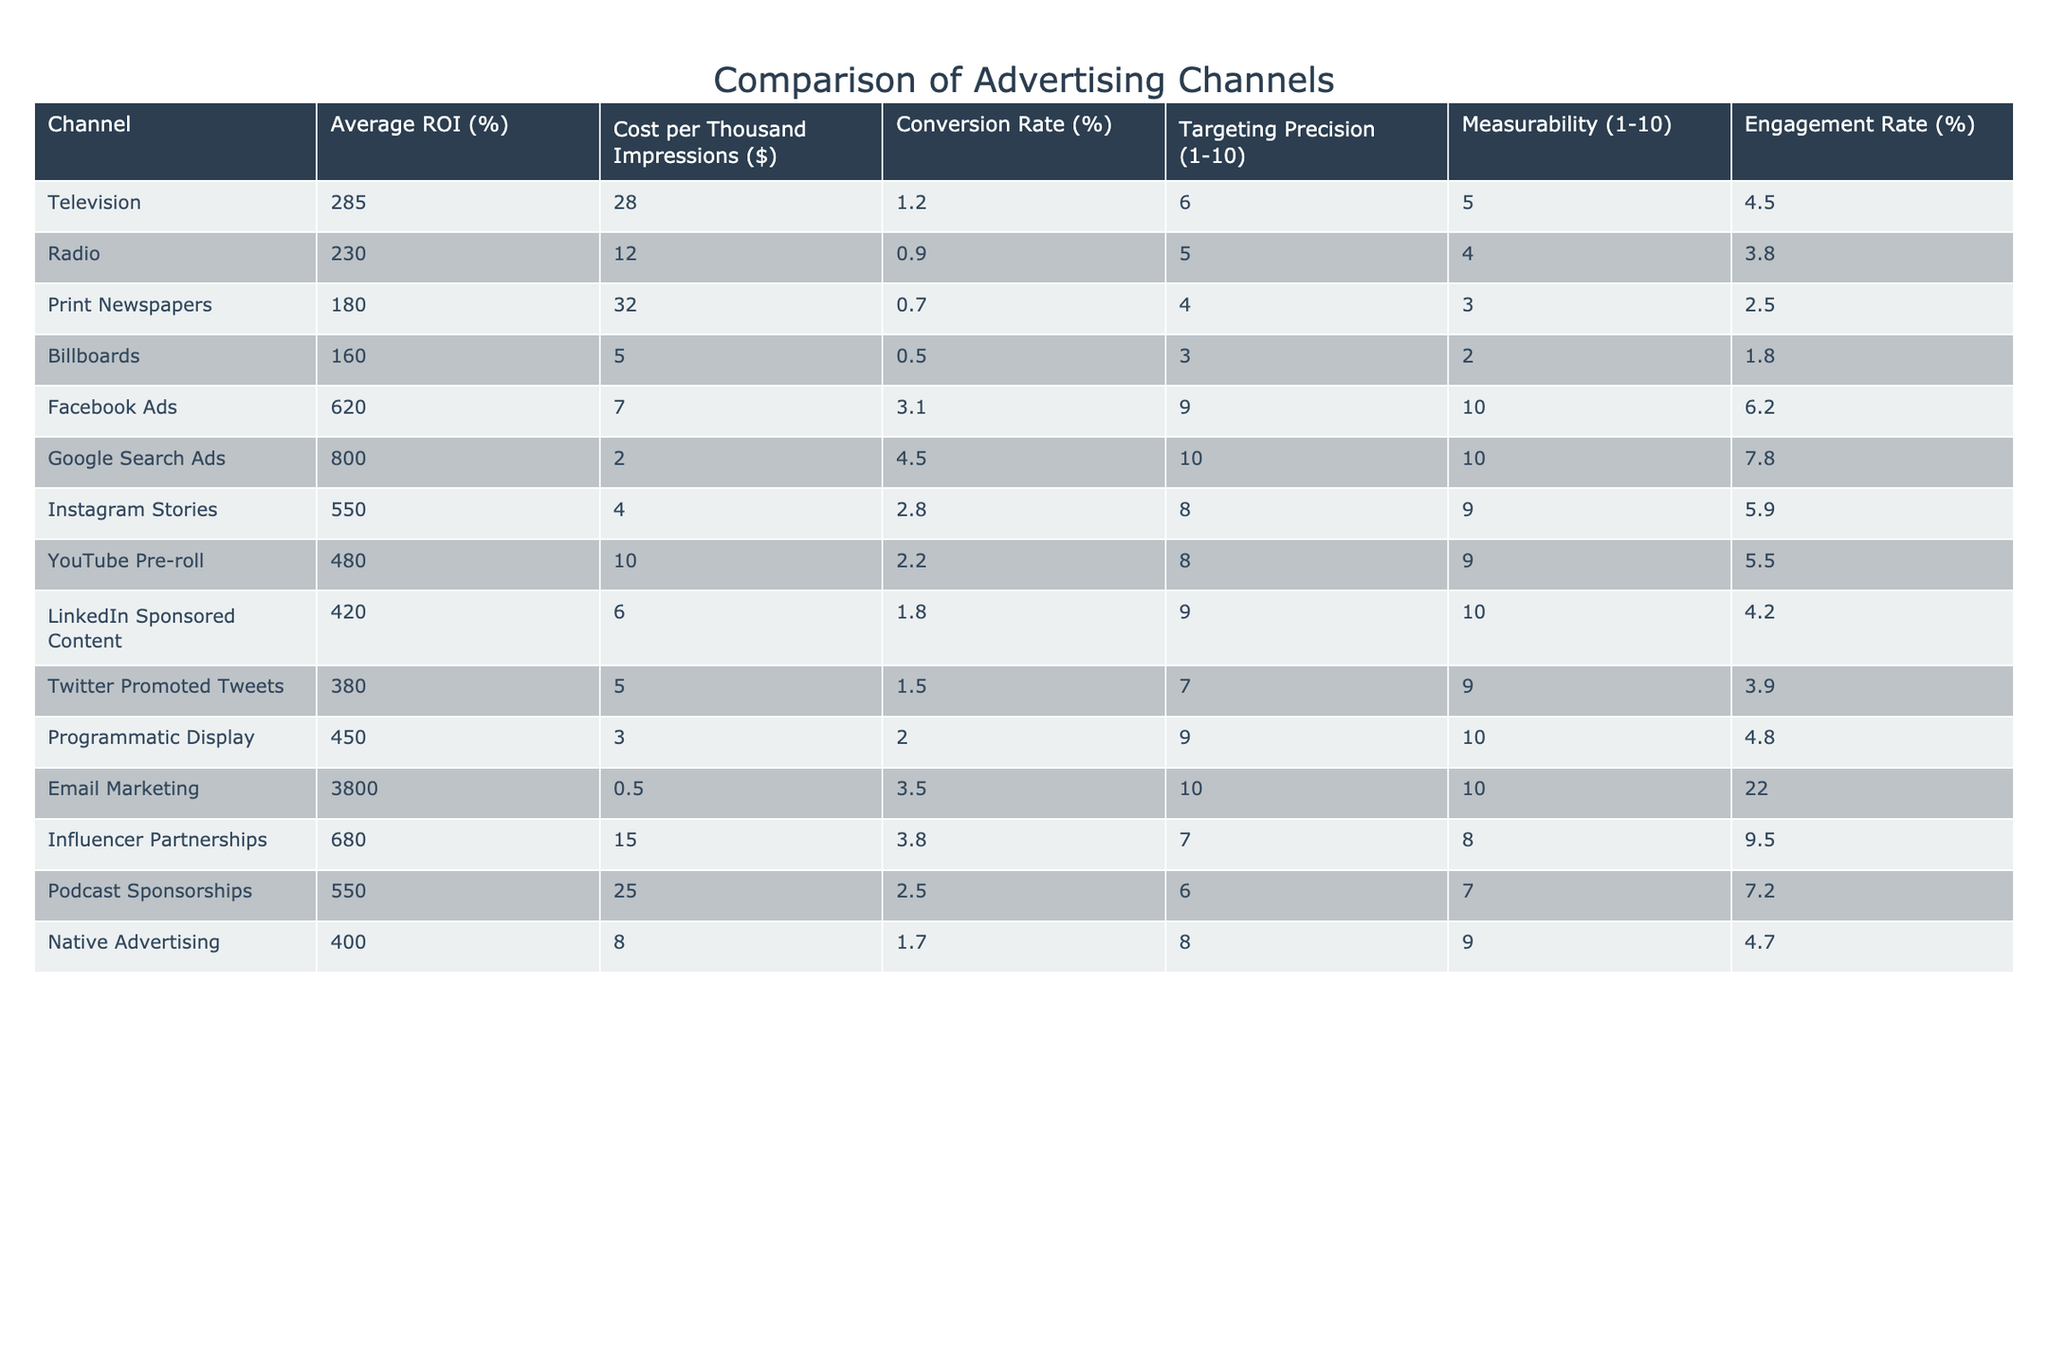What is the average ROI for digital advertising channels listed in the table? The digital advertising channels included are Facebook Ads, Google Search Ads, Instagram Stories, YouTube Pre-roll, LinkedIn Sponsored Content, Twitter Promoted Tweets, Programmatic Display, Email Marketing, Influencer Partnerships, Podcast Sponsorships, and Native Advertising. Their respective ROIs are 620, 800, 550, 480, 420, 380, 450, 3800, 680, 550, and 400. The sum of these values is 7920, and since there are 11 channels, the average ROI is 7920/11 = 720.
Answer: 720 Which traditional advertising channel has the highest conversion rate? The traditional advertising channels in the table are Television, Radio, Print Newspapers, and Billboards, with conversion rates of 1.2%, 0.9%, 0.7%, and 0.5%, respectively. Television has the highest conversion rate at 1.2%.
Answer: 1.2% Is the targeting precision of Google Search Ads higher than that of Facebook Ads? Google Search Ads has a targeting precision score of 10, while Facebook Ads has a score of 9. Since 10 is greater than 9, the targeting precision of Google Search Ads is higher.
Answer: Yes Calculate the difference in average cost per thousand impressions between traditional and digital advertising channels. The average cost per thousand impressions for traditional channels (Television, Radio, Print Newspapers, and Billboards) is (28 + 12 + 32 + 5) / 4 = 19.25. The digital channels (Facebook Ads, Google Search Ads, Instagram Stories, YouTube Pre-roll, LinkedIn Sponsored Content, Twitter Promoted Tweets, Programmatic Display, Email Marketing, Influencer Partnerships, Podcast Sponsorships, and Native Advertising) total to (7 + 2 + 4 + 10 + 6 + 5 + 3 + 0.5 + 15 + 25 + 8) / 11 = 8.64. The difference is 19.25 - 8.64 = 10.61.
Answer: 10.61 Is the engagement rate for Email Marketing higher than that for Radio? The engagement rate for Email Marketing is 22.0%, while the engagement rate for Radio is 3.8%. Since 22.0% is greater than 3.8%, Email Marketing's engagement rate is indeed higher.
Answer: Yes What is the relationship between cost per thousand impressions and average ROI for the channels listed? To analyze the relationship, we can observe the patterns: Generally, the channels with lower costs per thousand impressions tend to show higher ROIs (for example, Email Marketing with a cost of 0.5 has the highest ROI of 3800), while higher-cost channels like Print Newspapers ($32) have lower ROIs (180). This suggests an inverse correlation.
Answer: Inverse correlation 